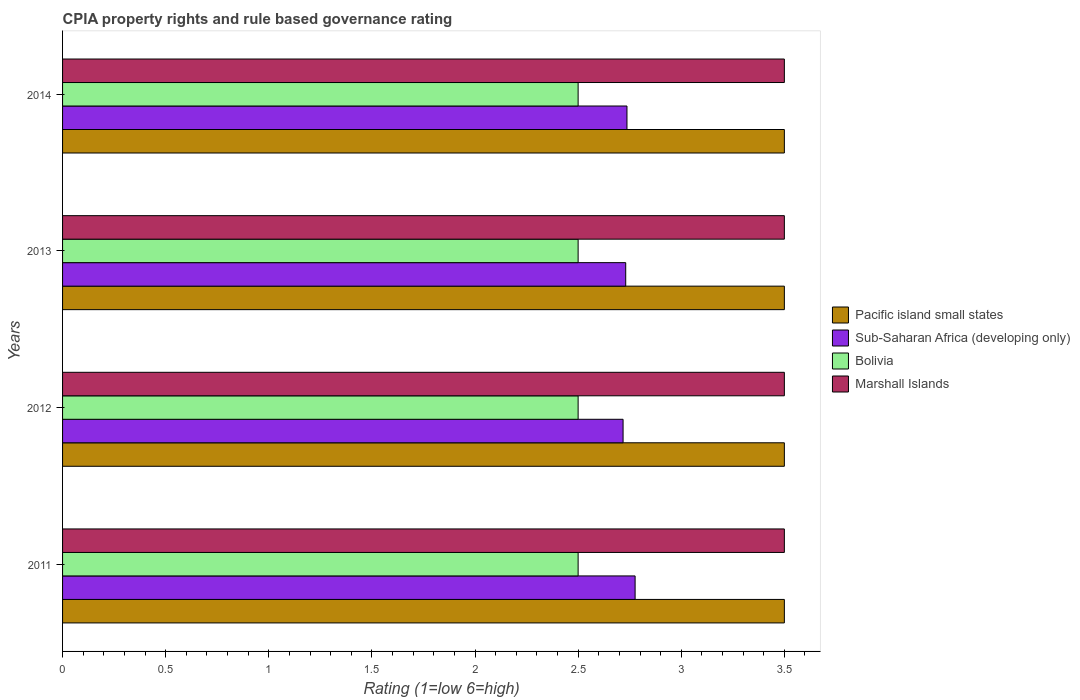How many different coloured bars are there?
Offer a terse response. 4. How many groups of bars are there?
Your answer should be very brief. 4. In how many cases, is the number of bars for a given year not equal to the number of legend labels?
Offer a very short reply. 0. Across all years, what is the minimum CPIA rating in Sub-Saharan Africa (developing only)?
Provide a short and direct response. 2.72. In which year was the CPIA rating in Sub-Saharan Africa (developing only) maximum?
Offer a terse response. 2011. In which year was the CPIA rating in Pacific island small states minimum?
Your response must be concise. 2011. What is the difference between the CPIA rating in Sub-Saharan Africa (developing only) in 2012 and that in 2013?
Offer a very short reply. -0.01. What is the difference between the CPIA rating in Bolivia in 2011 and the CPIA rating in Marshall Islands in 2013?
Provide a succinct answer. -1. What is the average CPIA rating in Bolivia per year?
Your answer should be very brief. 2.5. In the year 2013, what is the difference between the CPIA rating in Marshall Islands and CPIA rating in Sub-Saharan Africa (developing only)?
Offer a terse response. 0.77. In how many years, is the CPIA rating in Sub-Saharan Africa (developing only) greater than 1.7 ?
Your response must be concise. 4. What is the ratio of the CPIA rating in Sub-Saharan Africa (developing only) in 2013 to that in 2014?
Provide a succinct answer. 1. Is the CPIA rating in Marshall Islands in 2013 less than that in 2014?
Offer a terse response. No. What is the difference between the highest and the second highest CPIA rating in Bolivia?
Keep it short and to the point. 0. What is the difference between the highest and the lowest CPIA rating in Sub-Saharan Africa (developing only)?
Keep it short and to the point. 0.06. Is the sum of the CPIA rating in Pacific island small states in 2011 and 2012 greater than the maximum CPIA rating in Sub-Saharan Africa (developing only) across all years?
Provide a short and direct response. Yes. Is it the case that in every year, the sum of the CPIA rating in Sub-Saharan Africa (developing only) and CPIA rating in Bolivia is greater than the sum of CPIA rating in Marshall Islands and CPIA rating in Pacific island small states?
Offer a very short reply. No. What does the 3rd bar from the top in 2013 represents?
Your response must be concise. Sub-Saharan Africa (developing only). Is it the case that in every year, the sum of the CPIA rating in Marshall Islands and CPIA rating in Sub-Saharan Africa (developing only) is greater than the CPIA rating in Bolivia?
Offer a very short reply. Yes. How many bars are there?
Ensure brevity in your answer.  16. Are all the bars in the graph horizontal?
Ensure brevity in your answer.  Yes. How many years are there in the graph?
Provide a short and direct response. 4. What is the difference between two consecutive major ticks on the X-axis?
Your answer should be very brief. 0.5. Does the graph contain any zero values?
Offer a terse response. No. Does the graph contain grids?
Keep it short and to the point. No. Where does the legend appear in the graph?
Your answer should be compact. Center right. How many legend labels are there?
Ensure brevity in your answer.  4. What is the title of the graph?
Keep it short and to the point. CPIA property rights and rule based governance rating. Does "Georgia" appear as one of the legend labels in the graph?
Keep it short and to the point. No. What is the Rating (1=low 6=high) in Sub-Saharan Africa (developing only) in 2011?
Offer a very short reply. 2.78. What is the Rating (1=low 6=high) in Pacific island small states in 2012?
Provide a short and direct response. 3.5. What is the Rating (1=low 6=high) in Sub-Saharan Africa (developing only) in 2012?
Offer a terse response. 2.72. What is the Rating (1=low 6=high) of Bolivia in 2012?
Your answer should be compact. 2.5. What is the Rating (1=low 6=high) in Marshall Islands in 2012?
Provide a short and direct response. 3.5. What is the Rating (1=low 6=high) of Sub-Saharan Africa (developing only) in 2013?
Your answer should be compact. 2.73. What is the Rating (1=low 6=high) of Marshall Islands in 2013?
Your answer should be very brief. 3.5. What is the Rating (1=low 6=high) of Sub-Saharan Africa (developing only) in 2014?
Offer a terse response. 2.74. What is the Rating (1=low 6=high) of Bolivia in 2014?
Make the answer very short. 2.5. What is the Rating (1=low 6=high) in Marshall Islands in 2014?
Your answer should be very brief. 3.5. Across all years, what is the maximum Rating (1=low 6=high) in Pacific island small states?
Your answer should be compact. 3.5. Across all years, what is the maximum Rating (1=low 6=high) of Sub-Saharan Africa (developing only)?
Your answer should be compact. 2.78. Across all years, what is the maximum Rating (1=low 6=high) of Bolivia?
Give a very brief answer. 2.5. Across all years, what is the minimum Rating (1=low 6=high) of Sub-Saharan Africa (developing only)?
Give a very brief answer. 2.72. Across all years, what is the minimum Rating (1=low 6=high) in Bolivia?
Your answer should be compact. 2.5. What is the total Rating (1=low 6=high) of Sub-Saharan Africa (developing only) in the graph?
Your answer should be very brief. 10.96. What is the total Rating (1=low 6=high) of Bolivia in the graph?
Provide a short and direct response. 10. What is the difference between the Rating (1=low 6=high) in Sub-Saharan Africa (developing only) in 2011 and that in 2012?
Ensure brevity in your answer.  0.06. What is the difference between the Rating (1=low 6=high) in Marshall Islands in 2011 and that in 2012?
Your answer should be very brief. 0. What is the difference between the Rating (1=low 6=high) in Sub-Saharan Africa (developing only) in 2011 and that in 2013?
Give a very brief answer. 0.05. What is the difference between the Rating (1=low 6=high) in Sub-Saharan Africa (developing only) in 2011 and that in 2014?
Give a very brief answer. 0.04. What is the difference between the Rating (1=low 6=high) in Bolivia in 2011 and that in 2014?
Your answer should be very brief. 0. What is the difference between the Rating (1=low 6=high) in Sub-Saharan Africa (developing only) in 2012 and that in 2013?
Provide a succinct answer. -0.01. What is the difference between the Rating (1=low 6=high) of Marshall Islands in 2012 and that in 2013?
Offer a terse response. 0. What is the difference between the Rating (1=low 6=high) in Sub-Saharan Africa (developing only) in 2012 and that in 2014?
Offer a very short reply. -0.02. What is the difference between the Rating (1=low 6=high) of Pacific island small states in 2013 and that in 2014?
Your response must be concise. 0. What is the difference between the Rating (1=low 6=high) in Sub-Saharan Africa (developing only) in 2013 and that in 2014?
Give a very brief answer. -0.01. What is the difference between the Rating (1=low 6=high) of Bolivia in 2013 and that in 2014?
Your answer should be compact. 0. What is the difference between the Rating (1=low 6=high) in Marshall Islands in 2013 and that in 2014?
Offer a very short reply. 0. What is the difference between the Rating (1=low 6=high) in Pacific island small states in 2011 and the Rating (1=low 6=high) in Sub-Saharan Africa (developing only) in 2012?
Your response must be concise. 0.78. What is the difference between the Rating (1=low 6=high) in Pacific island small states in 2011 and the Rating (1=low 6=high) in Bolivia in 2012?
Offer a very short reply. 1. What is the difference between the Rating (1=low 6=high) of Pacific island small states in 2011 and the Rating (1=low 6=high) of Marshall Islands in 2012?
Make the answer very short. 0. What is the difference between the Rating (1=low 6=high) in Sub-Saharan Africa (developing only) in 2011 and the Rating (1=low 6=high) in Bolivia in 2012?
Offer a terse response. 0.28. What is the difference between the Rating (1=low 6=high) of Sub-Saharan Africa (developing only) in 2011 and the Rating (1=low 6=high) of Marshall Islands in 2012?
Ensure brevity in your answer.  -0.72. What is the difference between the Rating (1=low 6=high) of Pacific island small states in 2011 and the Rating (1=low 6=high) of Sub-Saharan Africa (developing only) in 2013?
Provide a succinct answer. 0.77. What is the difference between the Rating (1=low 6=high) in Sub-Saharan Africa (developing only) in 2011 and the Rating (1=low 6=high) in Bolivia in 2013?
Your answer should be very brief. 0.28. What is the difference between the Rating (1=low 6=high) of Sub-Saharan Africa (developing only) in 2011 and the Rating (1=low 6=high) of Marshall Islands in 2013?
Your answer should be very brief. -0.72. What is the difference between the Rating (1=low 6=high) in Pacific island small states in 2011 and the Rating (1=low 6=high) in Sub-Saharan Africa (developing only) in 2014?
Your answer should be compact. 0.76. What is the difference between the Rating (1=low 6=high) in Pacific island small states in 2011 and the Rating (1=low 6=high) in Marshall Islands in 2014?
Your answer should be compact. 0. What is the difference between the Rating (1=low 6=high) of Sub-Saharan Africa (developing only) in 2011 and the Rating (1=low 6=high) of Bolivia in 2014?
Offer a terse response. 0.28. What is the difference between the Rating (1=low 6=high) in Sub-Saharan Africa (developing only) in 2011 and the Rating (1=low 6=high) in Marshall Islands in 2014?
Provide a short and direct response. -0.72. What is the difference between the Rating (1=low 6=high) of Bolivia in 2011 and the Rating (1=low 6=high) of Marshall Islands in 2014?
Your answer should be compact. -1. What is the difference between the Rating (1=low 6=high) in Pacific island small states in 2012 and the Rating (1=low 6=high) in Sub-Saharan Africa (developing only) in 2013?
Provide a succinct answer. 0.77. What is the difference between the Rating (1=low 6=high) of Sub-Saharan Africa (developing only) in 2012 and the Rating (1=low 6=high) of Bolivia in 2013?
Make the answer very short. 0.22. What is the difference between the Rating (1=low 6=high) of Sub-Saharan Africa (developing only) in 2012 and the Rating (1=low 6=high) of Marshall Islands in 2013?
Ensure brevity in your answer.  -0.78. What is the difference between the Rating (1=low 6=high) of Bolivia in 2012 and the Rating (1=low 6=high) of Marshall Islands in 2013?
Your response must be concise. -1. What is the difference between the Rating (1=low 6=high) in Pacific island small states in 2012 and the Rating (1=low 6=high) in Sub-Saharan Africa (developing only) in 2014?
Provide a short and direct response. 0.76. What is the difference between the Rating (1=low 6=high) of Sub-Saharan Africa (developing only) in 2012 and the Rating (1=low 6=high) of Bolivia in 2014?
Provide a succinct answer. 0.22. What is the difference between the Rating (1=low 6=high) in Sub-Saharan Africa (developing only) in 2012 and the Rating (1=low 6=high) in Marshall Islands in 2014?
Offer a terse response. -0.78. What is the difference between the Rating (1=low 6=high) of Bolivia in 2012 and the Rating (1=low 6=high) of Marshall Islands in 2014?
Your response must be concise. -1. What is the difference between the Rating (1=low 6=high) in Pacific island small states in 2013 and the Rating (1=low 6=high) in Sub-Saharan Africa (developing only) in 2014?
Your answer should be very brief. 0.76. What is the difference between the Rating (1=low 6=high) of Pacific island small states in 2013 and the Rating (1=low 6=high) of Bolivia in 2014?
Keep it short and to the point. 1. What is the difference between the Rating (1=low 6=high) of Pacific island small states in 2013 and the Rating (1=low 6=high) of Marshall Islands in 2014?
Your answer should be compact. 0. What is the difference between the Rating (1=low 6=high) in Sub-Saharan Africa (developing only) in 2013 and the Rating (1=low 6=high) in Bolivia in 2014?
Ensure brevity in your answer.  0.23. What is the difference between the Rating (1=low 6=high) in Sub-Saharan Africa (developing only) in 2013 and the Rating (1=low 6=high) in Marshall Islands in 2014?
Give a very brief answer. -0.77. What is the difference between the Rating (1=low 6=high) in Bolivia in 2013 and the Rating (1=low 6=high) in Marshall Islands in 2014?
Your answer should be very brief. -1. What is the average Rating (1=low 6=high) in Pacific island small states per year?
Your answer should be compact. 3.5. What is the average Rating (1=low 6=high) of Sub-Saharan Africa (developing only) per year?
Your response must be concise. 2.74. What is the average Rating (1=low 6=high) of Marshall Islands per year?
Your answer should be very brief. 3.5. In the year 2011, what is the difference between the Rating (1=low 6=high) of Pacific island small states and Rating (1=low 6=high) of Sub-Saharan Africa (developing only)?
Offer a terse response. 0.72. In the year 2011, what is the difference between the Rating (1=low 6=high) of Pacific island small states and Rating (1=low 6=high) of Bolivia?
Ensure brevity in your answer.  1. In the year 2011, what is the difference between the Rating (1=low 6=high) in Sub-Saharan Africa (developing only) and Rating (1=low 6=high) in Bolivia?
Your answer should be compact. 0.28. In the year 2011, what is the difference between the Rating (1=low 6=high) of Sub-Saharan Africa (developing only) and Rating (1=low 6=high) of Marshall Islands?
Offer a terse response. -0.72. In the year 2012, what is the difference between the Rating (1=low 6=high) in Pacific island small states and Rating (1=low 6=high) in Sub-Saharan Africa (developing only)?
Provide a short and direct response. 0.78. In the year 2012, what is the difference between the Rating (1=low 6=high) of Sub-Saharan Africa (developing only) and Rating (1=low 6=high) of Bolivia?
Ensure brevity in your answer.  0.22. In the year 2012, what is the difference between the Rating (1=low 6=high) of Sub-Saharan Africa (developing only) and Rating (1=low 6=high) of Marshall Islands?
Make the answer very short. -0.78. In the year 2012, what is the difference between the Rating (1=low 6=high) of Bolivia and Rating (1=low 6=high) of Marshall Islands?
Make the answer very short. -1. In the year 2013, what is the difference between the Rating (1=low 6=high) of Pacific island small states and Rating (1=low 6=high) of Sub-Saharan Africa (developing only)?
Provide a succinct answer. 0.77. In the year 2013, what is the difference between the Rating (1=low 6=high) in Pacific island small states and Rating (1=low 6=high) in Marshall Islands?
Ensure brevity in your answer.  0. In the year 2013, what is the difference between the Rating (1=low 6=high) of Sub-Saharan Africa (developing only) and Rating (1=low 6=high) of Bolivia?
Your response must be concise. 0.23. In the year 2013, what is the difference between the Rating (1=low 6=high) in Sub-Saharan Africa (developing only) and Rating (1=low 6=high) in Marshall Islands?
Ensure brevity in your answer.  -0.77. In the year 2013, what is the difference between the Rating (1=low 6=high) of Bolivia and Rating (1=low 6=high) of Marshall Islands?
Your answer should be very brief. -1. In the year 2014, what is the difference between the Rating (1=low 6=high) in Pacific island small states and Rating (1=low 6=high) in Sub-Saharan Africa (developing only)?
Give a very brief answer. 0.76. In the year 2014, what is the difference between the Rating (1=low 6=high) of Pacific island small states and Rating (1=low 6=high) of Marshall Islands?
Give a very brief answer. 0. In the year 2014, what is the difference between the Rating (1=low 6=high) of Sub-Saharan Africa (developing only) and Rating (1=low 6=high) of Bolivia?
Your response must be concise. 0.24. In the year 2014, what is the difference between the Rating (1=low 6=high) in Sub-Saharan Africa (developing only) and Rating (1=low 6=high) in Marshall Islands?
Offer a terse response. -0.76. In the year 2014, what is the difference between the Rating (1=low 6=high) of Bolivia and Rating (1=low 6=high) of Marshall Islands?
Your response must be concise. -1. What is the ratio of the Rating (1=low 6=high) in Sub-Saharan Africa (developing only) in 2011 to that in 2012?
Ensure brevity in your answer.  1.02. What is the ratio of the Rating (1=low 6=high) of Bolivia in 2011 to that in 2012?
Offer a very short reply. 1. What is the ratio of the Rating (1=low 6=high) of Marshall Islands in 2011 to that in 2012?
Your response must be concise. 1. What is the ratio of the Rating (1=low 6=high) of Sub-Saharan Africa (developing only) in 2011 to that in 2013?
Offer a terse response. 1.02. What is the ratio of the Rating (1=low 6=high) of Pacific island small states in 2011 to that in 2014?
Your response must be concise. 1. What is the ratio of the Rating (1=low 6=high) in Sub-Saharan Africa (developing only) in 2011 to that in 2014?
Your answer should be very brief. 1.01. What is the ratio of the Rating (1=low 6=high) of Bolivia in 2011 to that in 2014?
Your response must be concise. 1. What is the ratio of the Rating (1=low 6=high) in Marshall Islands in 2011 to that in 2014?
Offer a very short reply. 1. What is the ratio of the Rating (1=low 6=high) of Pacific island small states in 2012 to that in 2013?
Keep it short and to the point. 1. What is the ratio of the Rating (1=low 6=high) in Pacific island small states in 2013 to that in 2014?
Keep it short and to the point. 1. What is the ratio of the Rating (1=low 6=high) of Marshall Islands in 2013 to that in 2014?
Keep it short and to the point. 1. What is the difference between the highest and the second highest Rating (1=low 6=high) in Sub-Saharan Africa (developing only)?
Provide a short and direct response. 0.04. What is the difference between the highest and the lowest Rating (1=low 6=high) in Pacific island small states?
Keep it short and to the point. 0. What is the difference between the highest and the lowest Rating (1=low 6=high) of Sub-Saharan Africa (developing only)?
Provide a succinct answer. 0.06. What is the difference between the highest and the lowest Rating (1=low 6=high) of Bolivia?
Your answer should be very brief. 0. What is the difference between the highest and the lowest Rating (1=low 6=high) of Marshall Islands?
Ensure brevity in your answer.  0. 